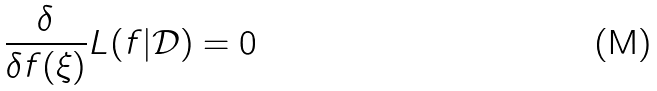<formula> <loc_0><loc_0><loc_500><loc_500>\frac { \delta } { \delta f ( \xi ) } L ( f | \mathcal { D } ) = 0</formula> 